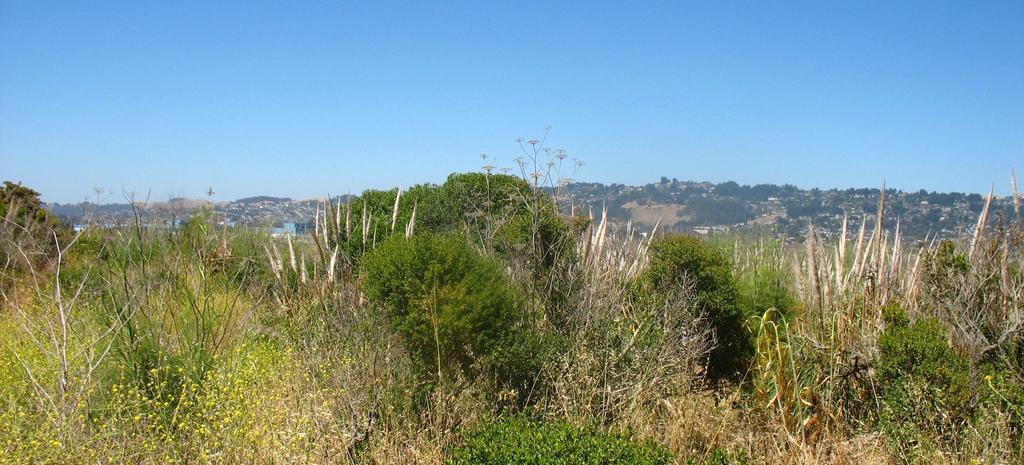Could you give a brief overview of what you see in this image? In this picture we can see the whole place is covered with grass. The sky is blue. 